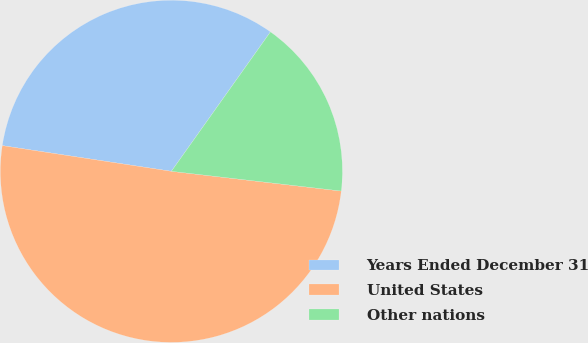<chart> <loc_0><loc_0><loc_500><loc_500><pie_chart><fcel>Years Ended December 31<fcel>United States<fcel>Other nations<nl><fcel>32.43%<fcel>50.56%<fcel>17.01%<nl></chart> 